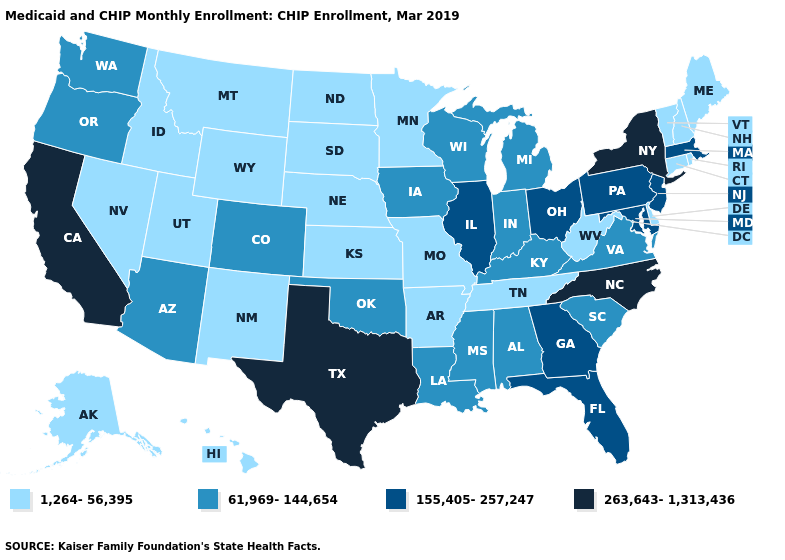What is the value of Mississippi?
Answer briefly. 61,969-144,654. Among the states that border Oregon , which have the highest value?
Concise answer only. California. Which states have the lowest value in the South?
Short answer required. Arkansas, Delaware, Tennessee, West Virginia. Is the legend a continuous bar?
Keep it brief. No. Name the states that have a value in the range 61,969-144,654?
Write a very short answer. Alabama, Arizona, Colorado, Indiana, Iowa, Kentucky, Louisiana, Michigan, Mississippi, Oklahoma, Oregon, South Carolina, Virginia, Washington, Wisconsin. What is the value of Wisconsin?
Quick response, please. 61,969-144,654. Does North Dakota have a higher value than Missouri?
Short answer required. No. Does Ohio have the highest value in the MidWest?
Concise answer only. Yes. Does Montana have the lowest value in the USA?
Keep it brief. Yes. Does Washington have the lowest value in the West?
Be succinct. No. What is the highest value in states that border Texas?
Keep it brief. 61,969-144,654. Name the states that have a value in the range 263,643-1,313,436?
Short answer required. California, New York, North Carolina, Texas. How many symbols are there in the legend?
Be succinct. 4. Does California have the highest value in the West?
Write a very short answer. Yes. Does Nebraska have a lower value than Florida?
Be succinct. Yes. 